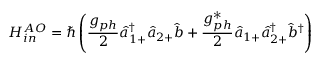<formula> <loc_0><loc_0><loc_500><loc_500>H _ { i n } ^ { A O } = \hbar { \left } ( \frac { g _ { p h } } { 2 } \hat { a } _ { 1 + } ^ { \dagger } \hat { a } _ { 2 + } \hat { b } + \frac { g _ { p h } ^ { * } } { 2 } \hat { a } _ { 1 + } \hat { a } _ { 2 + } ^ { \dagger } \hat { b } ^ { \dagger } \right )</formula> 